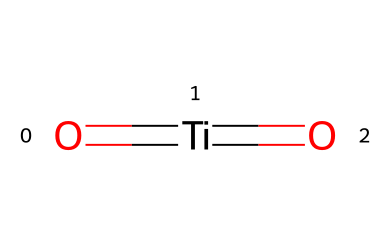What is the central atom in this structure? The central atom can be identified as titanium (Ti), which is represented by the atom that forms the central coordinate bonds with oxygens in the structure.
Answer: titanium How many oxygen atoms are present? The SMILES representation shows two oxygen atoms connected to the titanium atom, indicated by the two "O" characters at each end of the structure.
Answer: two What is the oxidation state of titanium in titanium dioxide? In titanium dioxide, titanium is in the +4 oxidation state, as it forms bonds with two oxygen atoms, each typically in the -2 oxidation state, resulting in a neutral compound (4 - 4 = 0).
Answer: +4 What type of bonds are present in titanium dioxide? The bonds in titanium dioxide consist of double bonds between titanium and each oxygen atom. This is indicated by the "=" sign in the SMILES notation.
Answer: double bonds What is the primary use of titanium dioxide? Titanium dioxide is primarily used as a white pigment in paints and coatings, providing opacity and brightness.
Answer: pigment 